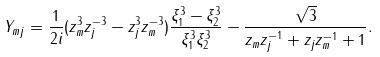Convert formula to latex. <formula><loc_0><loc_0><loc_500><loc_500>Y _ { m j } = \frac { 1 } { 2 i } ( z _ { m } ^ { 3 } z _ { j } ^ { - 3 } - z _ { j } ^ { 3 } z _ { m } ^ { - 3 } ) \frac { \xi _ { 1 } ^ { 3 } - \xi _ { 2 } ^ { 3 } } { \xi _ { 1 } ^ { 3 } \xi _ { 2 } ^ { 3 } } - \frac { \sqrt { 3 } } { z _ { m } z _ { j } ^ { - 1 } + z _ { j } z _ { m } ^ { - 1 } + 1 } .</formula> 